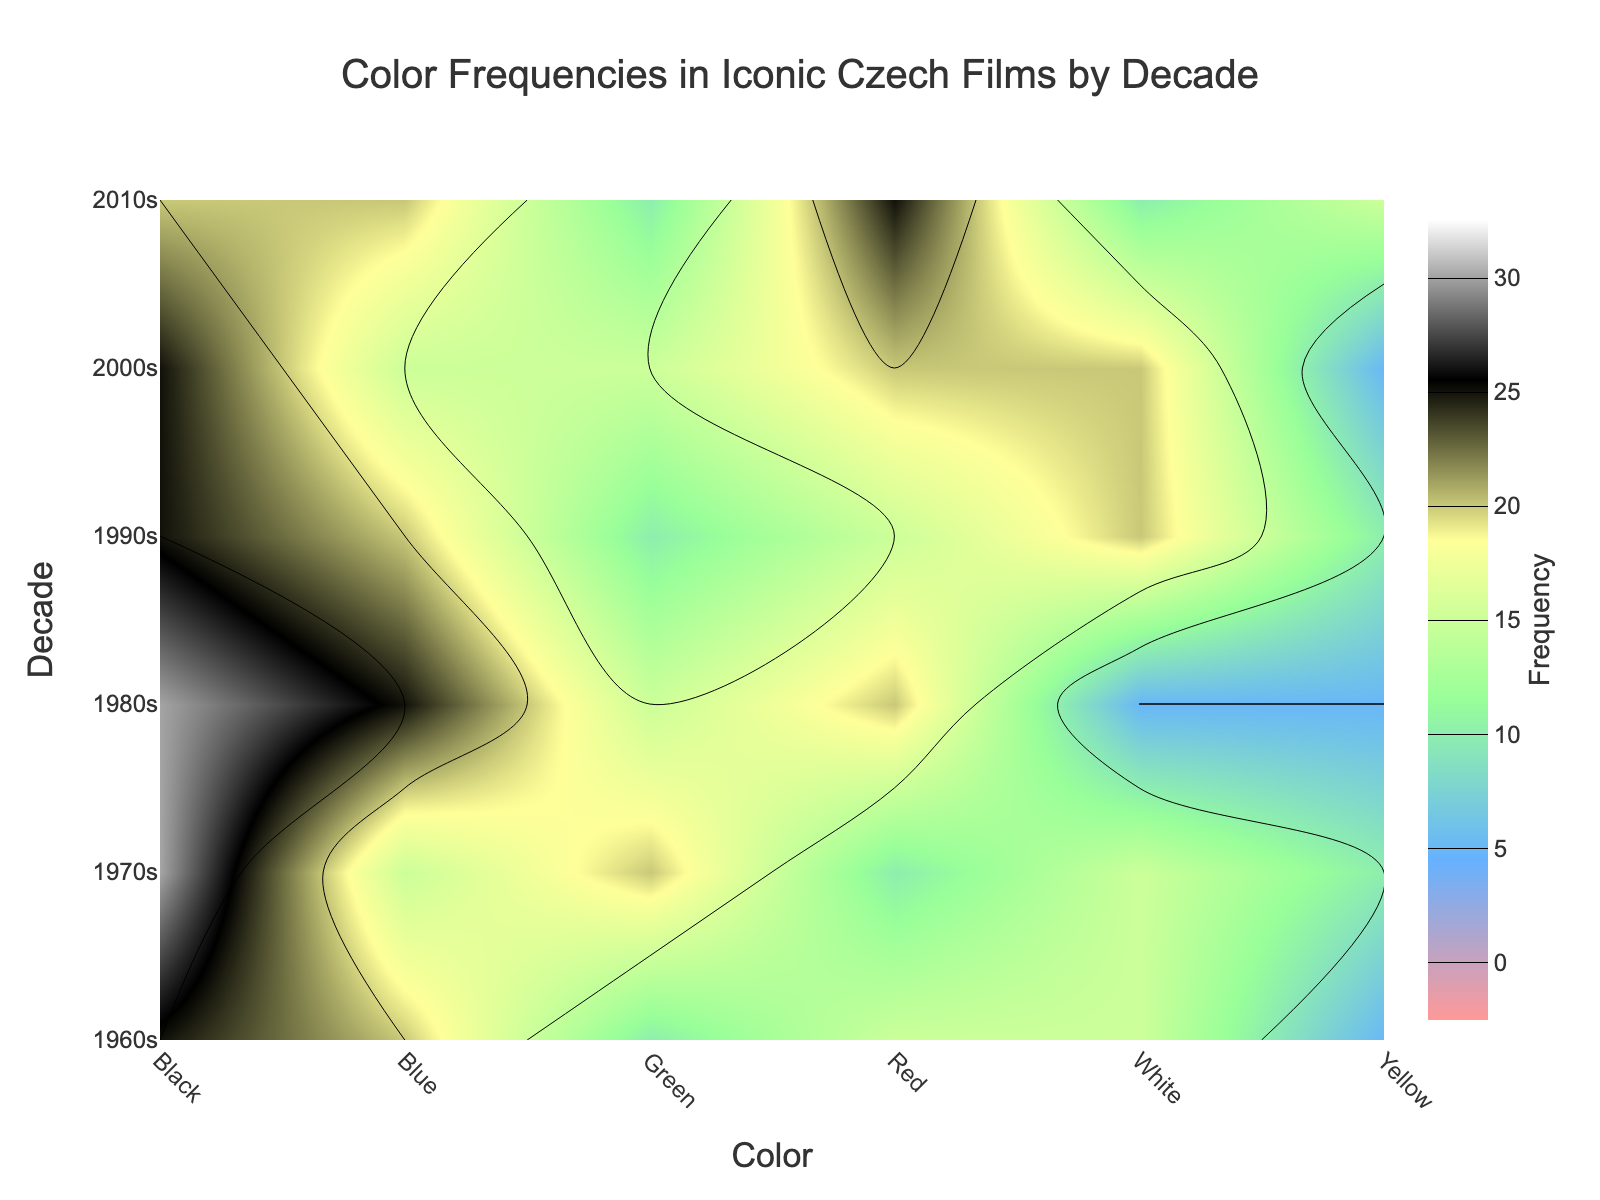What's the title of the figure? The title of the figure is usually placed prominently at the top. By looking at the top of the figure, you can see the text that describes what the plot is about.
Answer: Color Frequencies in Iconic Czech Films by Decade What are the axes labels? Axes labels provide context to the data plotted along the x-axis and y-axis. By examining the figure, you can read the labels directly from the axes.
Answer: x-axis: Color, y-axis: Decade Which color had the highest frequency in the 2010s? To find the highest frequency for the 2010s, locate the row representing the 2010s on the y-axis and check the corresponding values for each color on the x-axis. Identify the highest value.
Answer: Red Which decade had the highest frequency for the color Blue? Scan along the column for Blue and identify the decade corresponding to the highest value within that column.
Answer: 1980s What is the range of values shown on the color bar? The color bar represents the range of data values encoded by colors. By looking at the start and end values of the color bar, you can determine this range.
Answer: 0 to 30 What is the total frequency of the color Black across all decades? Sum up the values for the color Black across all decades from the corresponding rows. Add the frequencies for Black in each decade to find the total.
Answer: 155 Compare the frequency of Red in the 1960s to the frequency of Red in the 2000s. Which is higher? Look at the frequencies of Red for the 1960s and the 2000s and compare the two values to determine which is higher.
Answer: 2000s Which decade shows the most balanced use of colors (i.e., the least variation in frequency among colors)? Locate the decade that has the closest values for each color. Measure the variation by looking at the spread or differences in values for colors associated with each decade.
Answer: 1970s What is the difference in frequency of the color White between the 1990s and 2010s? Subtract the frequency of White in the 2010s from the frequency of White in the 1990s to find the difference.
Answer: 10 Which colors show a decreasing trend in frequency from the 1980s to the 2010s? For each color, trace the values from the 1980s to the 2010s. Identify which colors have a decreasing pattern over these decades.
Answer: Black, White 